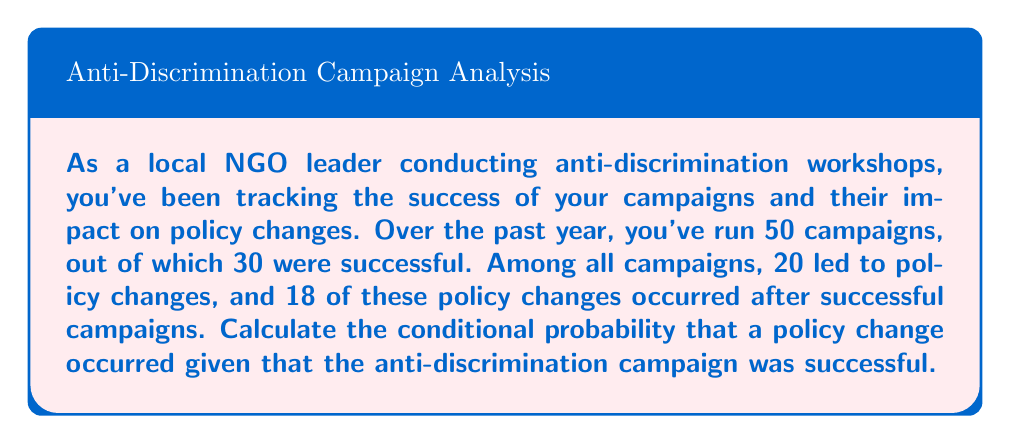Can you solve this math problem? Let's approach this step-by-step using the given information:

1) Define events:
   S: Successful campaign
   P: Policy change occurred

2) Given probabilities:
   P(S) = 30/50 = 0.6 (probability of a successful campaign)
   P(P) = 20/50 = 0.4 (probability of a policy change)
   P(P ∩ S) = 18/50 = 0.36 (probability of both policy change and successful campaign)

3) We need to find P(P|S), which is the conditional probability of a policy change given a successful campaign.

4) The formula for conditional probability is:

   $$P(P|S) = \frac{P(P ∩ S)}{P(S)}$$

5) Substituting the values:

   $$P(P|S) = \frac{0.36}{0.6}$$

6) Calculating:

   $$P(P|S) = 0.6 = 60\%$$

Therefore, the conditional probability that a policy change occurred given that the anti-discrimination campaign was successful is 0.6 or 60%.
Answer: 0.6 